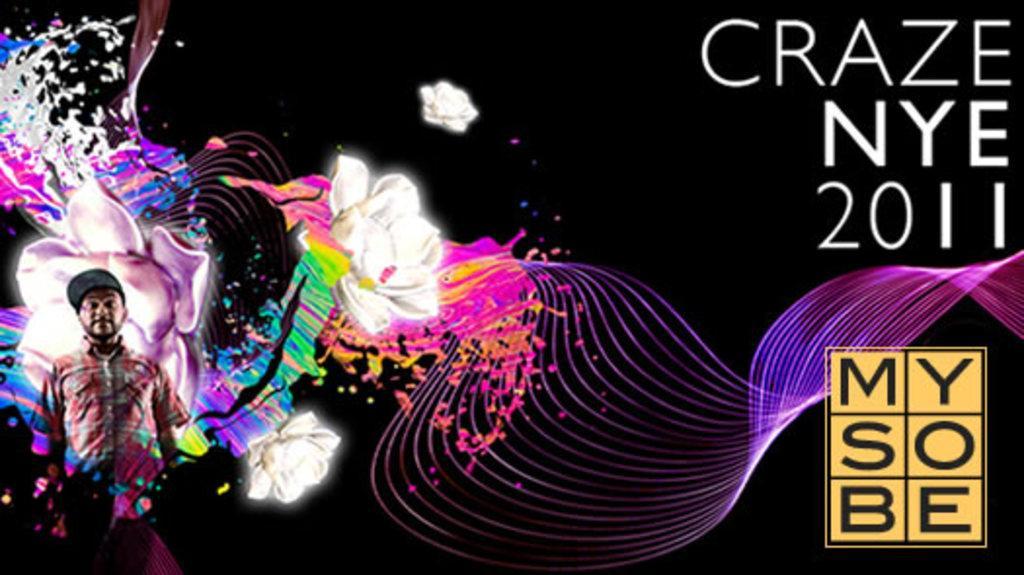Describe this image in one or two sentences. In this image we can see a person standing on the left side. 